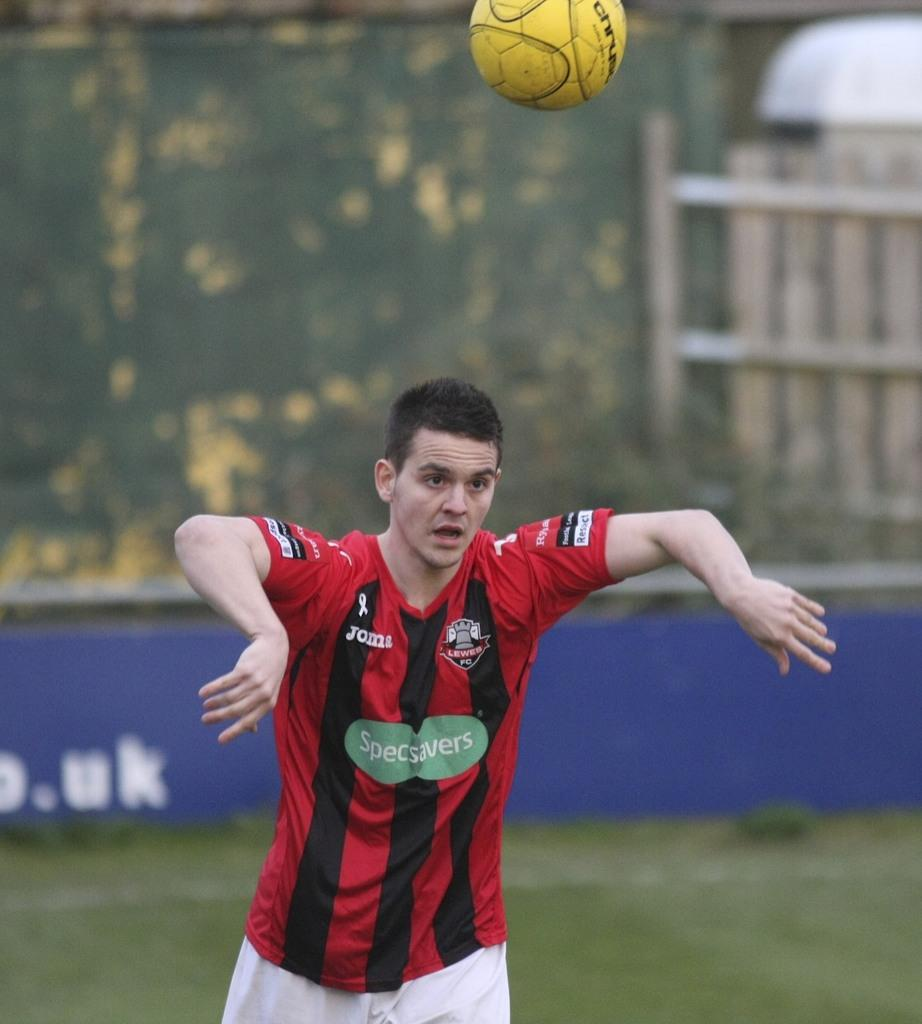What is the man doing in the image? The man is standing on the ground in the image. What else can be seen in the image besides the man? There is a ball in the air in the image. What holiday is the queen celebrating in the image? There is no queen or holiday present in the image; it only features a man standing on the ground and a ball in the air. What shape is the ball in the image? The provided facts do not mention the shape of the ball, so we cannot definitively answer that question. 